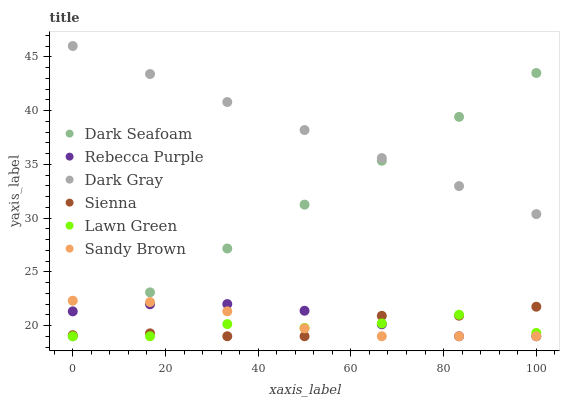Does Lawn Green have the minimum area under the curve?
Answer yes or no. Yes. Does Dark Gray have the maximum area under the curve?
Answer yes or no. Yes. Does Dark Gray have the minimum area under the curve?
Answer yes or no. No. Does Lawn Green have the maximum area under the curve?
Answer yes or no. No. Is Dark Seafoam the smoothest?
Answer yes or no. Yes. Is Lawn Green the roughest?
Answer yes or no. Yes. Is Dark Gray the smoothest?
Answer yes or no. No. Is Dark Gray the roughest?
Answer yes or no. No. Does Sienna have the lowest value?
Answer yes or no. Yes. Does Dark Gray have the lowest value?
Answer yes or no. No. Does Dark Gray have the highest value?
Answer yes or no. Yes. Does Lawn Green have the highest value?
Answer yes or no. No. Is Sandy Brown less than Dark Gray?
Answer yes or no. Yes. Is Dark Gray greater than Sandy Brown?
Answer yes or no. Yes. Does Lawn Green intersect Rebecca Purple?
Answer yes or no. Yes. Is Lawn Green less than Rebecca Purple?
Answer yes or no. No. Is Lawn Green greater than Rebecca Purple?
Answer yes or no. No. Does Sandy Brown intersect Dark Gray?
Answer yes or no. No. 